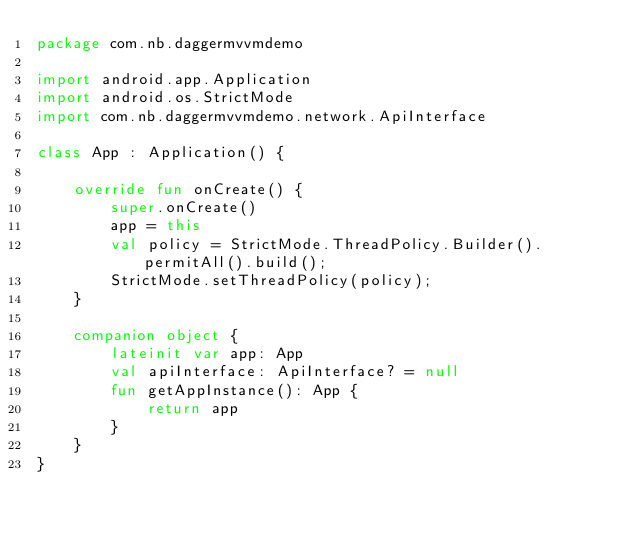<code> <loc_0><loc_0><loc_500><loc_500><_Kotlin_>package com.nb.daggermvvmdemo

import android.app.Application
import android.os.StrictMode
import com.nb.daggermvvmdemo.network.ApiInterface

class App : Application() {

    override fun onCreate() {
        super.onCreate()
        app = this
        val policy = StrictMode.ThreadPolicy.Builder().permitAll().build();
        StrictMode.setThreadPolicy(policy);
    }

    companion object {
        lateinit var app: App
        val apiInterface: ApiInterface? = null
        fun getAppInstance(): App {
            return app
        }
    }
}</code> 